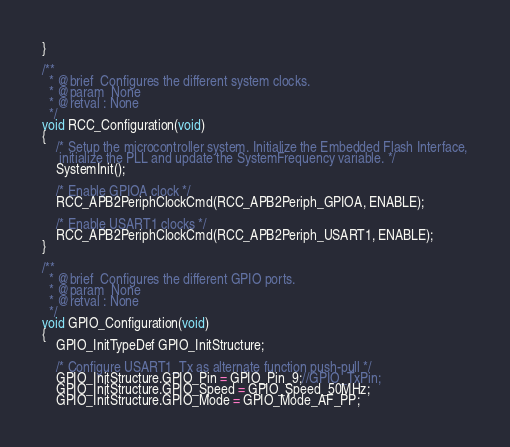Convert code to text. <code><loc_0><loc_0><loc_500><loc_500><_C_>}

/**
  * @brief  Configures the different system clocks.
  * @param  None
  * @retval : None
  */
void RCC_Configuration(void)
{
    /* Setup the microcontroller system. Initialize the Embedded Flash Interface,
     initialize the PLL and update the SystemFrequency variable. */
    SystemInit();

    /* Enable GPIOA clock */
    RCC_APB2PeriphClockCmd(RCC_APB2Periph_GPIOA, ENABLE);

    /* Enable USART1 clocks */
    RCC_APB2PeriphClockCmd(RCC_APB2Periph_USART1, ENABLE);
}

/**
  * @brief  Configures the different GPIO ports.
  * @param  None
  * @retval : None
  */
void GPIO_Configuration(void)
{
    GPIO_InitTypeDef GPIO_InitStructure;

    /* Configure USART1_Tx as alternate function push-pull */
    GPIO_InitStructure.GPIO_Pin = GPIO_Pin_9;//GPIO_TxPin;
    GPIO_InitStructure.GPIO_Speed = GPIO_Speed_50MHz;
    GPIO_InitStructure.GPIO_Mode = GPIO_Mode_AF_PP;</code> 